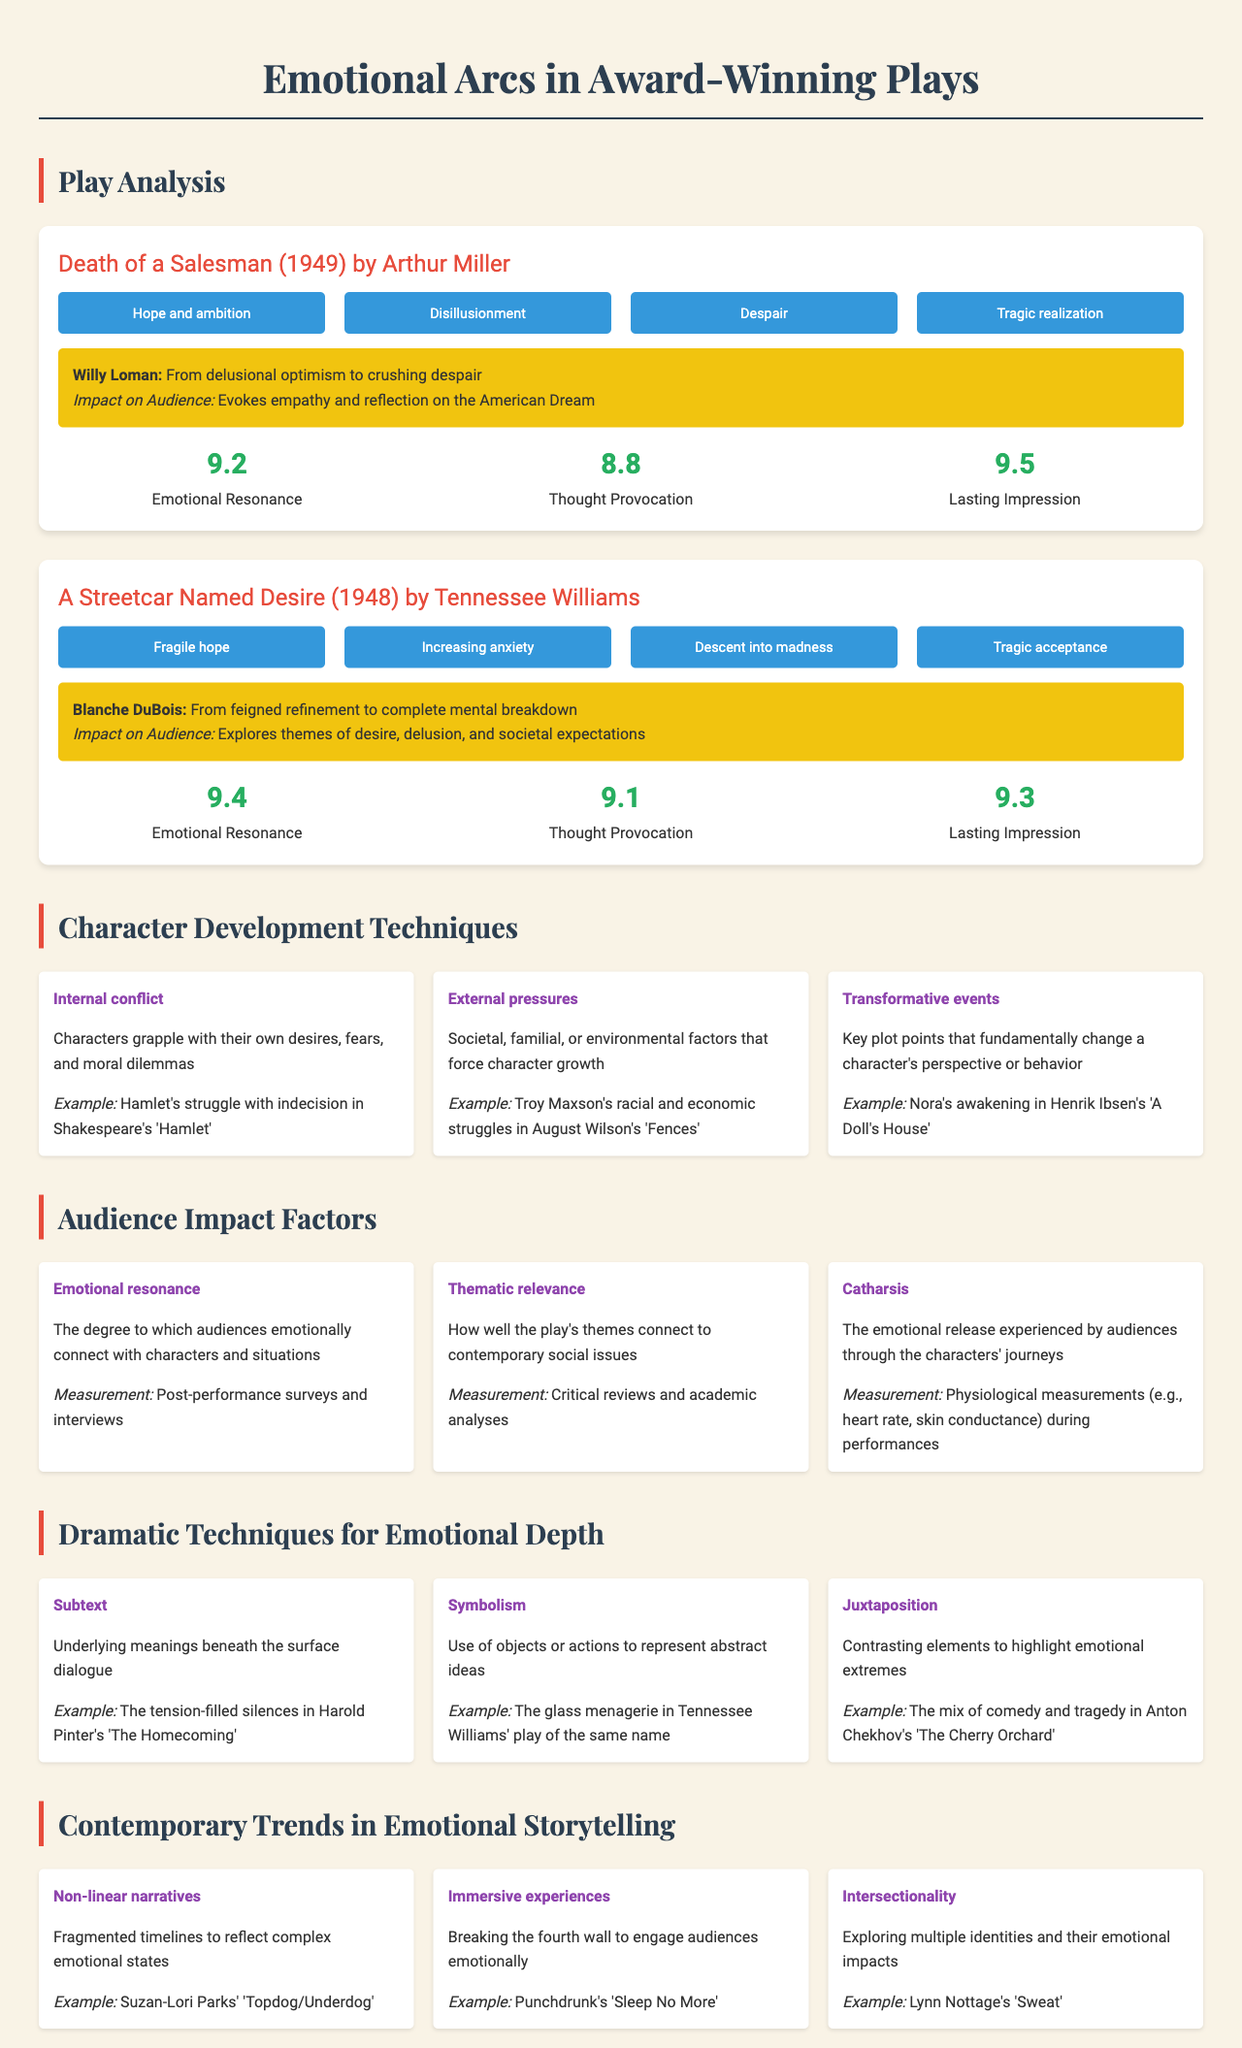what is the emotional arc of "Death of a Salesman"? The emotional arc for "Death of a Salesman" includes stages such as hope and ambition, disillusionment, despair, and tragic realization.
Answer: hope and ambition, disillusionment, despair, tragic realization who is the main character in "A Streetcar Named Desire"? The main character in "A Streetcar Named Desire" is identified as Blanche DuBois.
Answer: Blanche DuBois what year was "Death of a Salesman" awarded? The year "Death of a Salesman" was awarded is noted as 1949.
Answer: 1949 what is the emotional resonance score for "A Streetcar Named Desire"? The emotional resonance score for "A Streetcar Named Desire" is measured at 9.4.
Answer: 9.4 which character undergoes transformation due to external pressures in the analysis? The character who undergoes transformation due to external pressures is Troy Maxson in "Fences."
Answer: Troy Maxson what is the method used to measure emotional resonance? Emotional resonance is measured through post-performance surveys and interviews.
Answer: post-performance surveys and interviews what does the technique 'subtext' represent in dramatic storytelling? The technique 'subtext' represents underlying meanings beneath the surface dialogue.
Answer: underlying meanings beneath the surface dialogue which contemporary trend involves fragmented timelines? The contemporary trend that involves fragmented timelines is non-linear narratives.
Answer: non-linear narratives what is the average lasting impression score for the plays analyzed? The average lasting impression score is calculated from the plays and scored at 9.4.
Answer: 9.4 